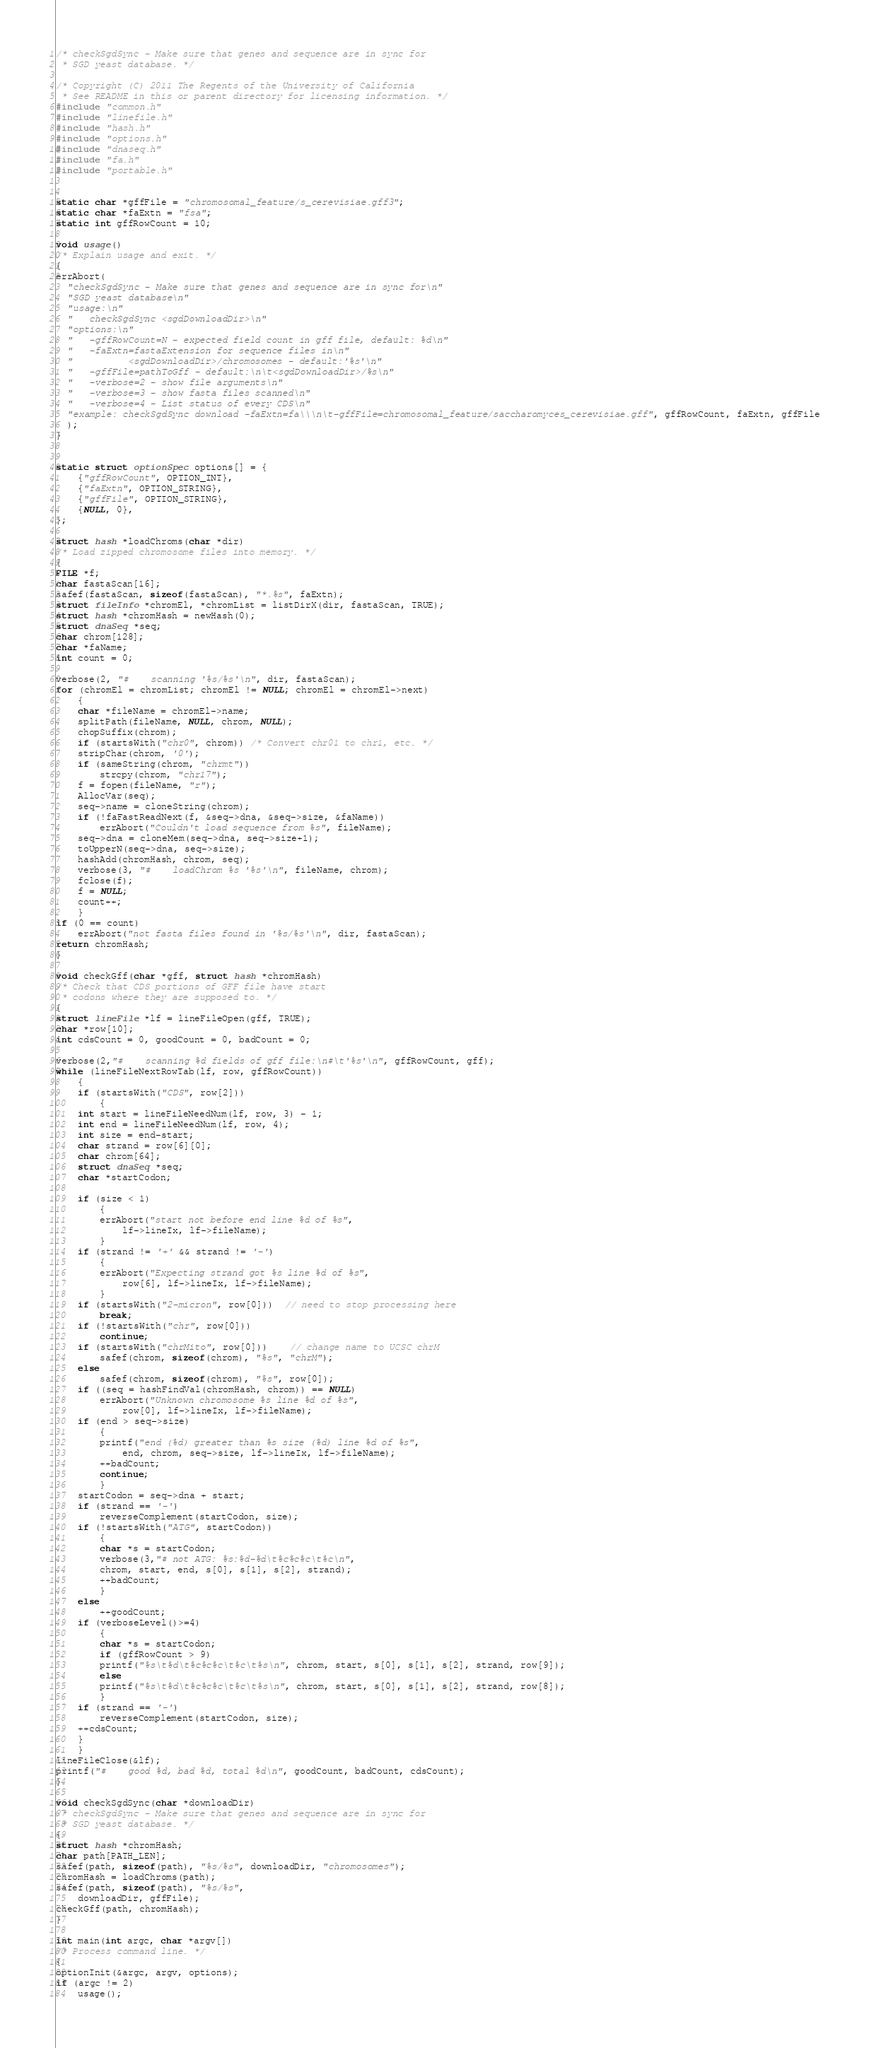Convert code to text. <code><loc_0><loc_0><loc_500><loc_500><_C_>/* checkSgdSync - Make sure that genes and sequence are in sync for 
 * SGD yeast database. */

/* Copyright (C) 2011 The Regents of the University of California 
 * See README in this or parent directory for licensing information. */
#include "common.h"
#include "linefile.h"
#include "hash.h"
#include "options.h"
#include "dnaseq.h"
#include "fa.h"
#include "portable.h"


static char *gffFile = "chromosomal_feature/s_cerevisiae.gff3";
static char *faExtn = "fsa";
static int gffRowCount = 10;

void usage()
/* Explain usage and exit. */
{
errAbort(
  "checkSgdSync - Make sure that genes and sequence are in sync for\n"
  "SGD yeast database\n"
  "usage:\n"
  "   checkSgdSync <sgdDownloadDir>\n"
  "options:\n"
  "   -gffRowCount=N - expected field count in gff file, default: %d\n"
  "   -faExtn=fastaExtension for sequence files in\n"
  "          <sgdDownloadDir>/chromosomes - default:'%s'\n"
  "   -gffFile=pathToGff - default:\n\t<sgdDownloadDir>/%s\n"
  "   -verbose=2 - show file arguments\n"
  "   -verbose=3 - show fasta files scanned\n"
  "   -verbose=4 - List status of every CDS\n"
  "example: checkSgdSync download -faExtn=fa\\\n\t-gffFile=chromosomal_feature/saccharomyces_cerevisiae.gff", gffRowCount, faExtn, gffFile
  );
}


static struct optionSpec options[] = {
    {"gffRowCount", OPTION_INT},
    {"faExtn", OPTION_STRING},
    {"gffFile", OPTION_STRING},
    {NULL, 0},
};

struct hash *loadChroms(char *dir)
/* Load zipped chromosome files into memory. */
{
FILE *f;
char fastaScan[16];
safef(fastaScan, sizeof(fastaScan), "*.%s", faExtn);
struct fileInfo *chromEl, *chromList = listDirX(dir, fastaScan, TRUE);
struct hash *chromHash = newHash(0);
struct dnaSeq *seq;
char chrom[128];
char *faName;
int count = 0;

verbose(2, "#    scanning '%s/%s'\n", dir, fastaScan);
for (chromEl = chromList; chromEl != NULL; chromEl = chromEl->next)
    {
    char *fileName = chromEl->name;
    splitPath(fileName, NULL, chrom, NULL);
    chopSuffix(chrom);
    if (startsWith("chr0", chrom)) /* Convert chr01 to chr1, etc. */
	stripChar(chrom, '0');
    if (sameString(chrom, "chrmt"))
        strcpy(chrom, "chr17");
    f = fopen(fileName, "r");
    AllocVar(seq);
    seq->name = cloneString(chrom);
    if (!faFastReadNext(f, &seq->dna, &seq->size, &faName))
        errAbort("Couldn't load sequence from %s", fileName);
    seq->dna = cloneMem(seq->dna, seq->size+1);
    toUpperN(seq->dna, seq->size);
    hashAdd(chromHash, chrom, seq);
    verbose(3, "#    loadChrom %s '%s'\n", fileName, chrom);
    fclose(f);
    f = NULL;
    count++;
    }
if (0 == count)
    errAbort("not fasta files found in '%s/%s'\n", dir, fastaScan);
return chromHash;
}

void checkGff(char *gff, struct hash *chromHash)
/* Check that CDS portions of GFF file have start
 * codons where they are supposed to. */
{
struct lineFile *lf = lineFileOpen(gff, TRUE);
char *row[10];
int cdsCount = 0, goodCount = 0, badCount = 0;

verbose(2,"#    scanning %d fields of gff file:\n#\t'%s'\n", gffRowCount, gff);
while (lineFileNextRowTab(lf, row, gffRowCount))
    {
    if (startsWith("CDS", row[2]))
        {
	int start = lineFileNeedNum(lf, row, 3) - 1;
	int end = lineFileNeedNum(lf, row, 4);
	int size = end-start;
	char strand = row[6][0];
	char chrom[64];
	struct dnaSeq *seq;
	char *startCodon;
	
	if (size < 1)
	    {
	    errAbort("start not before end line %d of %s",
	    	lf->lineIx, lf->fileName);
	    }
	if (strand != '+' && strand != '-')
	    {
	    errAbort("Expecting strand got %s line %d of %s",
	    	row[6], lf->lineIx, lf->fileName);
	    }
	if (startsWith("2-micron", row[0]))  // need to stop processing here
	    break;
	if (!startsWith("chr", row[0]))
	    continue;
	if (startsWith("chrMito", row[0]))	// change name to UCSC chrM
	    safef(chrom, sizeof(chrom), "%s", "chrM");
	else
	    safef(chrom, sizeof(chrom), "%s", row[0]);
	if ((seq = hashFindVal(chromHash, chrom)) == NULL)
	    errAbort("Unknown chromosome %s line %d of %s",
	    	row[0], lf->lineIx, lf->fileName);
	if (end > seq->size)
	    {
	    printf("end (%d) greater than %s size (%d) line %d of %s",
	        end, chrom, seq->size, lf->lineIx, lf->fileName);
	    ++badCount;
	    continue;
	    }
	startCodon = seq->dna + start;
	if (strand == '-')
	    reverseComplement(startCodon, size);
	if (!startsWith("ATG", startCodon))
	    {
	    char *s = startCodon;
	    verbose(3,"# not ATG: %s:%d-%d\t%c%c%c\t%c\n",
		chrom, start, end, s[0], s[1], s[2], strand);
	    ++badCount;
	    }
	else
	    ++goodCount;
	if (verboseLevel()>=4)
	    {
	    char *s = startCodon;
	    if (gffRowCount > 9)
		printf("%s\t%d\t%c%c%c\t%c\t%s\n", chrom, start, s[0], s[1], s[2], strand, row[9]);
	    else
		printf("%s\t%d\t%c%c%c\t%c\t%s\n", chrom, start, s[0], s[1], s[2], strand, row[8]);
	    }
	if (strand == '-')
	    reverseComplement(startCodon, size);
	++cdsCount;
	}
    }
lineFileClose(&lf);
printf("#    good %d, bad %d, total %d\n", goodCount, badCount, cdsCount);
}

void checkSgdSync(char *downloadDir)
/* checkSgdSync - Make sure that genes and sequence are in sync for 
 * SGD yeast database. */
{
struct hash *chromHash;
char path[PATH_LEN];
safef(path, sizeof(path), "%s/%s", downloadDir, "chromosomes");
chromHash = loadChroms(path);
safef(path, sizeof(path), "%s/%s", 
	downloadDir, gffFile);
checkGff(path, chromHash);
}

int main(int argc, char *argv[])
/* Process command line. */
{
optionInit(&argc, argv, options);
if (argc != 2)
    usage();</code> 